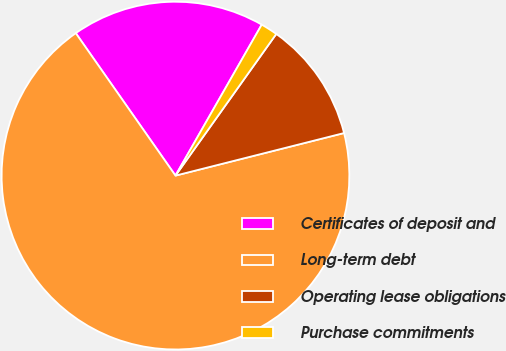<chart> <loc_0><loc_0><loc_500><loc_500><pie_chart><fcel>Certificates of deposit and<fcel>Long-term debt<fcel>Operating lease obligations<fcel>Purchase commitments<nl><fcel>17.98%<fcel>69.22%<fcel>11.22%<fcel>1.58%<nl></chart> 